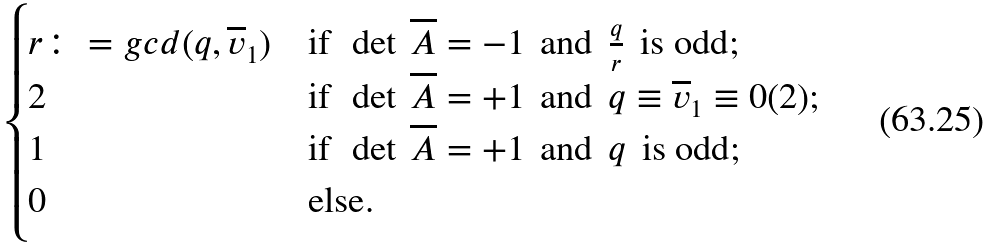Convert formula to latex. <formula><loc_0><loc_0><loc_500><loc_500>\begin{cases} r \colon = g c d ( q , \overline { v } _ { 1 } ) & \text {if } \, \det \, \overline { A } = - 1 \, \text { and } \, \frac { q } { r } \, \text { is odd} ; \\ 2 & \text {if } \, \det \, \overline { A } = + 1 \, \text { and } \, q \equiv \overline { v } _ { 1 } \equiv 0 ( 2 ) ; \\ 1 & \text {if } \, \det \, \overline { A } = + 1 \, \text { and } \, q \, \text { is odd} ; \\ 0 & \text {else} . \end{cases}</formula> 